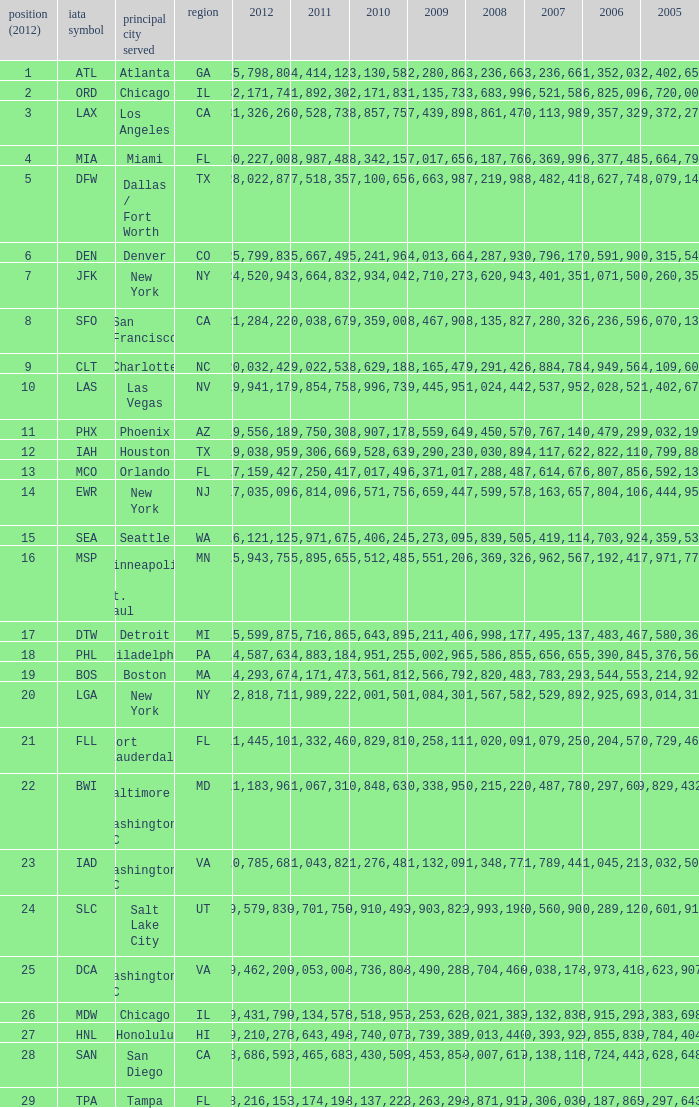For the IATA code of lax with 2009 less than 31,135,732 and 2011 less than 8,174,194, what is the sum of 2012? 0.0. 